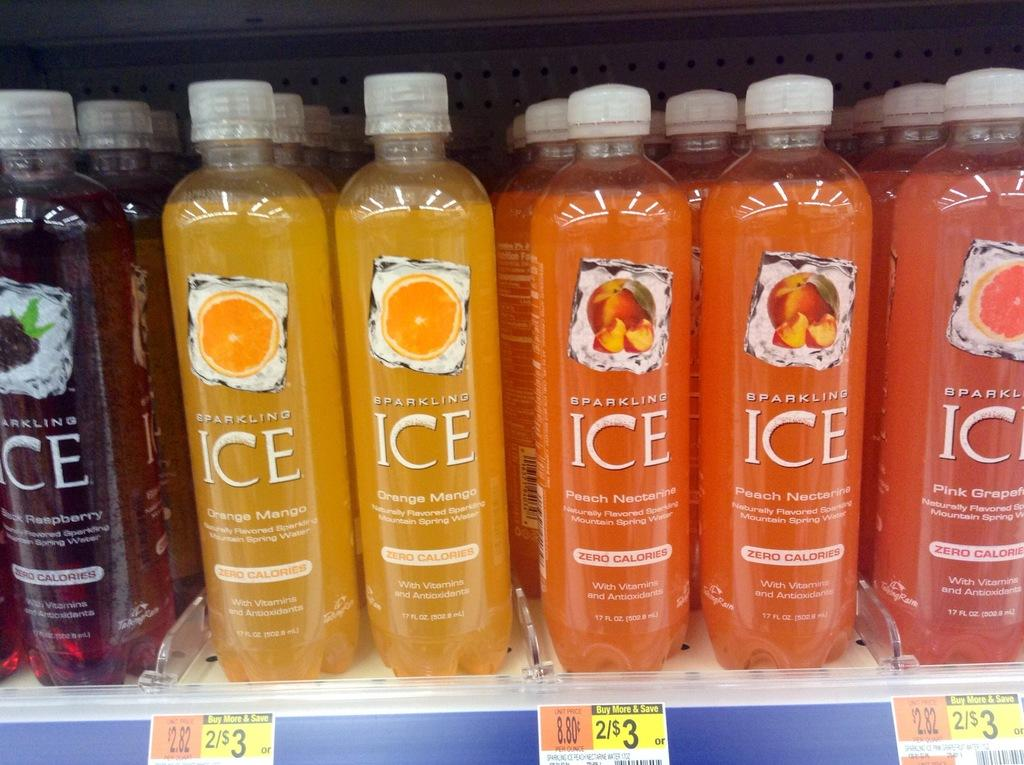Provide a one-sentence caption for the provided image. a grocery shelf of colorful Sparkling Ice drinks. 